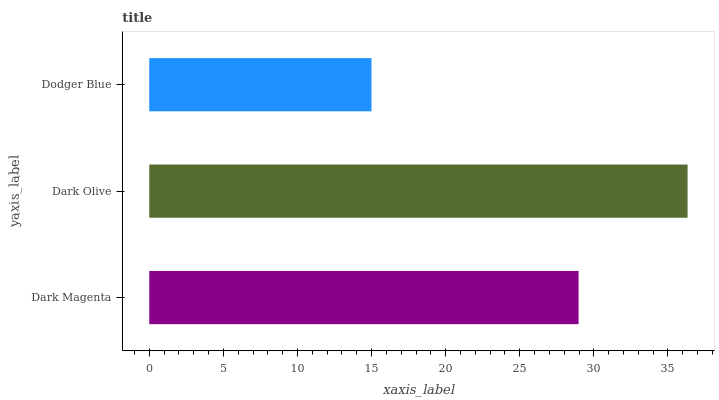Is Dodger Blue the minimum?
Answer yes or no. Yes. Is Dark Olive the maximum?
Answer yes or no. Yes. Is Dark Olive the minimum?
Answer yes or no. No. Is Dodger Blue the maximum?
Answer yes or no. No. Is Dark Olive greater than Dodger Blue?
Answer yes or no. Yes. Is Dodger Blue less than Dark Olive?
Answer yes or no. Yes. Is Dodger Blue greater than Dark Olive?
Answer yes or no. No. Is Dark Olive less than Dodger Blue?
Answer yes or no. No. Is Dark Magenta the high median?
Answer yes or no. Yes. Is Dark Magenta the low median?
Answer yes or no. Yes. Is Dark Olive the high median?
Answer yes or no. No. Is Dark Olive the low median?
Answer yes or no. No. 